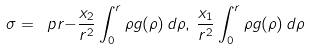<formula> <loc_0><loc_0><loc_500><loc_500>\sigma = \ p r { - \frac { x _ { 2 } } { r ^ { 2 } } \int _ { 0 } ^ { r } \rho g ( \rho ) \, d \rho , \, \frac { x _ { 1 } } { r ^ { 2 } } \int _ { 0 } ^ { r } \rho g ( \rho ) \, d \rho }</formula> 